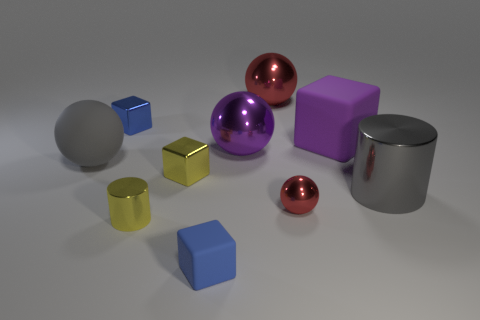How many objects are matte blocks that are right of the big red thing or matte blocks that are behind the small yellow shiny cylinder?
Ensure brevity in your answer.  1. There is another blue cube that is the same size as the blue matte cube; what is its material?
Ensure brevity in your answer.  Metal. The tiny ball is what color?
Your response must be concise. Red. What is the material of the large sphere that is both right of the yellow block and in front of the purple rubber block?
Your answer should be very brief. Metal. There is a small metal block in front of the large thing that is on the left side of the large purple metallic ball; are there any yellow things to the right of it?
Make the answer very short. No. What is the size of the sphere that is the same color as the big matte block?
Provide a succinct answer. Large. Are there any rubber objects on the right side of the large red object?
Your answer should be compact. Yes. What number of other objects are there of the same shape as the purple metal object?
Your answer should be compact. 3. What is the color of the matte cube that is the same size as the blue metallic cube?
Offer a very short reply. Blue. Is the number of large gray rubber spheres that are behind the big purple sphere less than the number of blue metal cubes that are to the left of the gray rubber thing?
Offer a very short reply. No. 